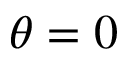<formula> <loc_0><loc_0><loc_500><loc_500>\theta = 0</formula> 